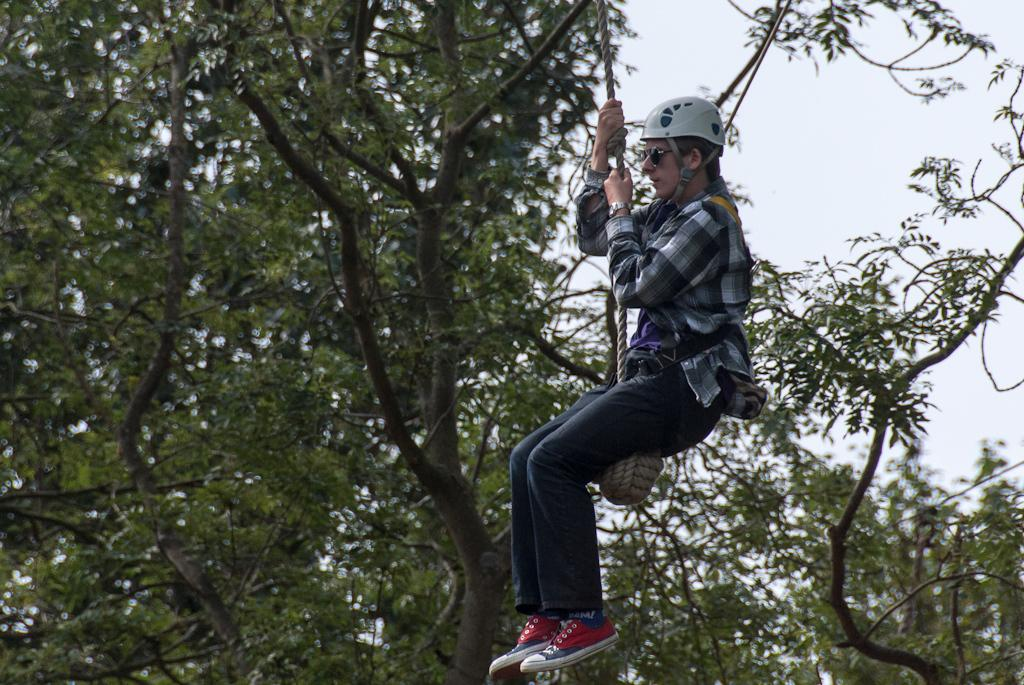Who is present in the image? There is a man in the image. What is the man doing in the image? The man is hanging from a rope. What can be seen in the background of the image? There are trees and the sky visible in the background of the image. What type of plant is growing in the water near the man? There is no plant growing in the water near the man in the image. 